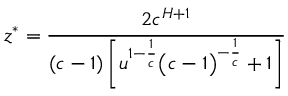<formula> <loc_0><loc_0><loc_500><loc_500>z ^ { * } = \cfrac { 2 c ^ { H + 1 } } { ( c - 1 ) \left [ u ^ { 1 - \frac { 1 } { c } } \left ( c - 1 \right ) ^ { - \frac { 1 } { c } } + 1 \right ] }</formula> 